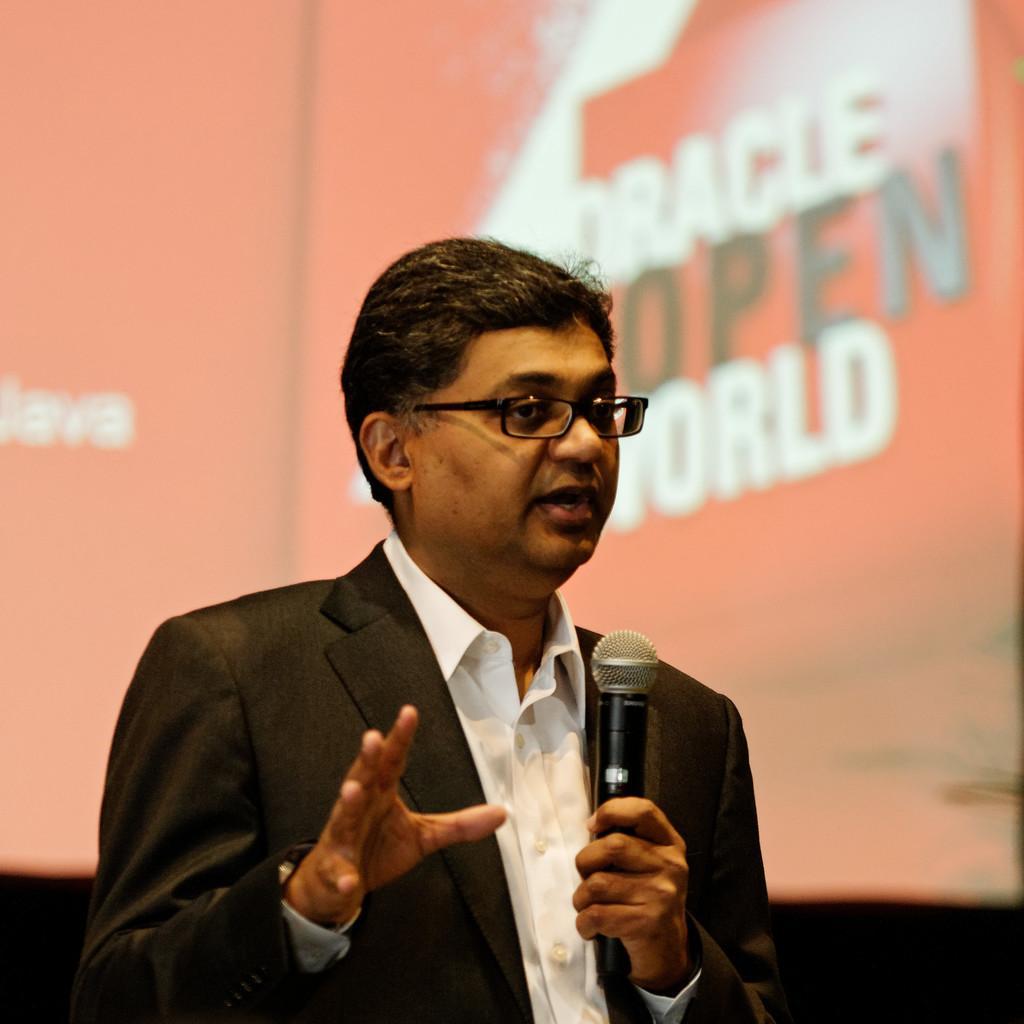In one or two sentences, can you explain what this image depicts? In this image I can see a person holding a mike and wearing a spectacle , in the background I can see a orange color board, on the board I can see a text. 